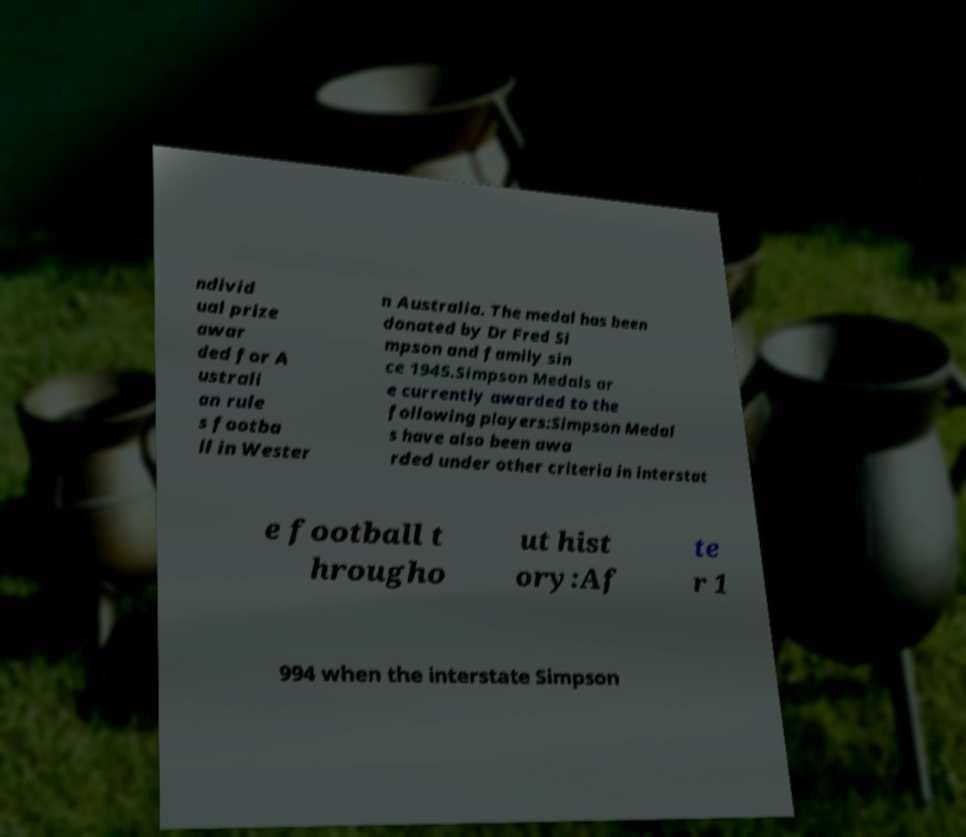There's text embedded in this image that I need extracted. Can you transcribe it verbatim? ndivid ual prize awar ded for A ustrali an rule s footba ll in Wester n Australia. The medal has been donated by Dr Fred Si mpson and family sin ce 1945.Simpson Medals ar e currently awarded to the following players:Simpson Medal s have also been awa rded under other criteria in interstat e football t hrougho ut hist ory:Af te r 1 994 when the interstate Simpson 